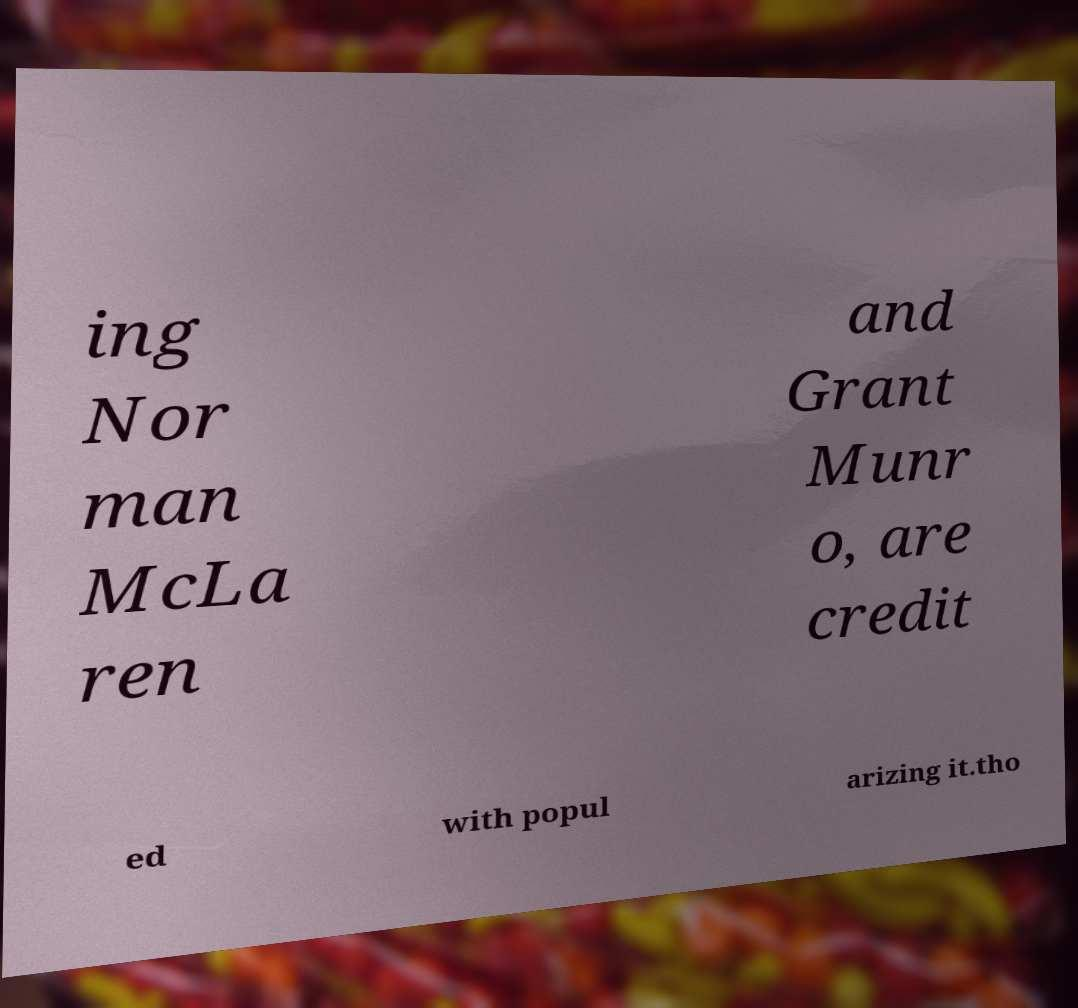I need the written content from this picture converted into text. Can you do that? ing Nor man McLa ren and Grant Munr o, are credit ed with popul arizing it.tho 